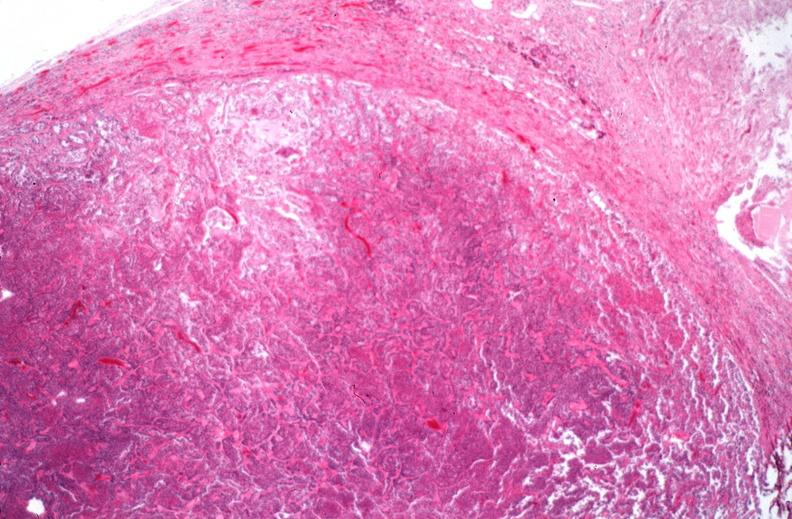does this image show pituitary, chromaphobe adenoma?
Answer the question using a single word or phrase. Yes 